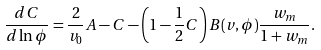<formula> <loc_0><loc_0><loc_500><loc_500>\frac { d C } { d \ln \phi } & = \frac { 2 } { v _ { 0 } } A - C - \left ( 1 - \frac { 1 } { 2 } C \right ) B ( v , \phi ) \frac { w _ { m } } { 1 + w _ { m } } .</formula> 